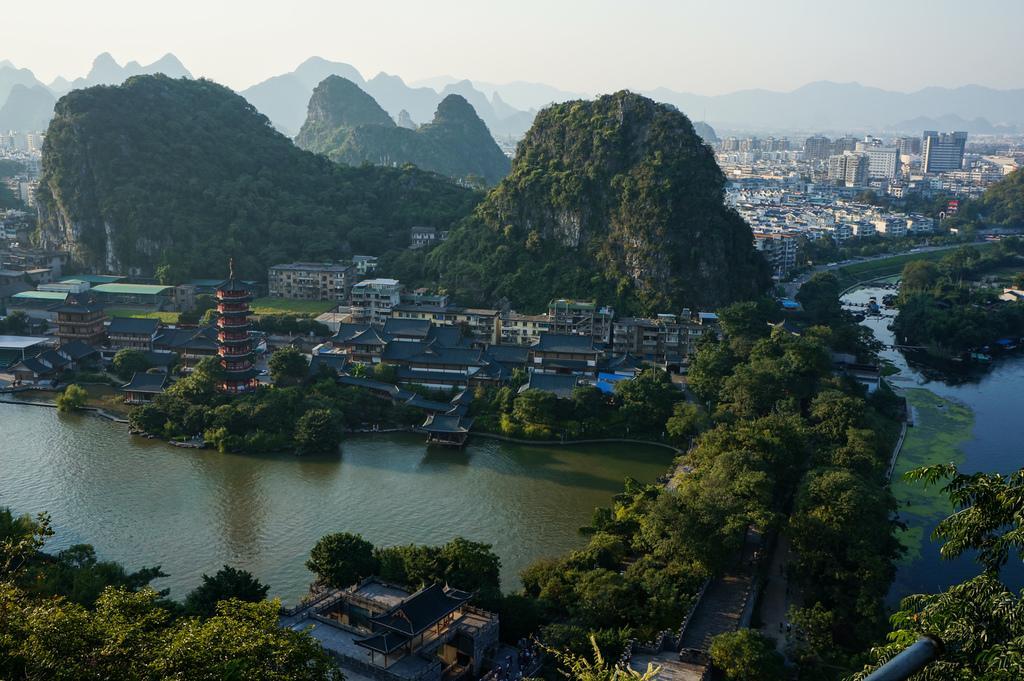Can you describe this image briefly? In this image, in the middle there are buildings, trees, hills, water, road, grass, sky. 